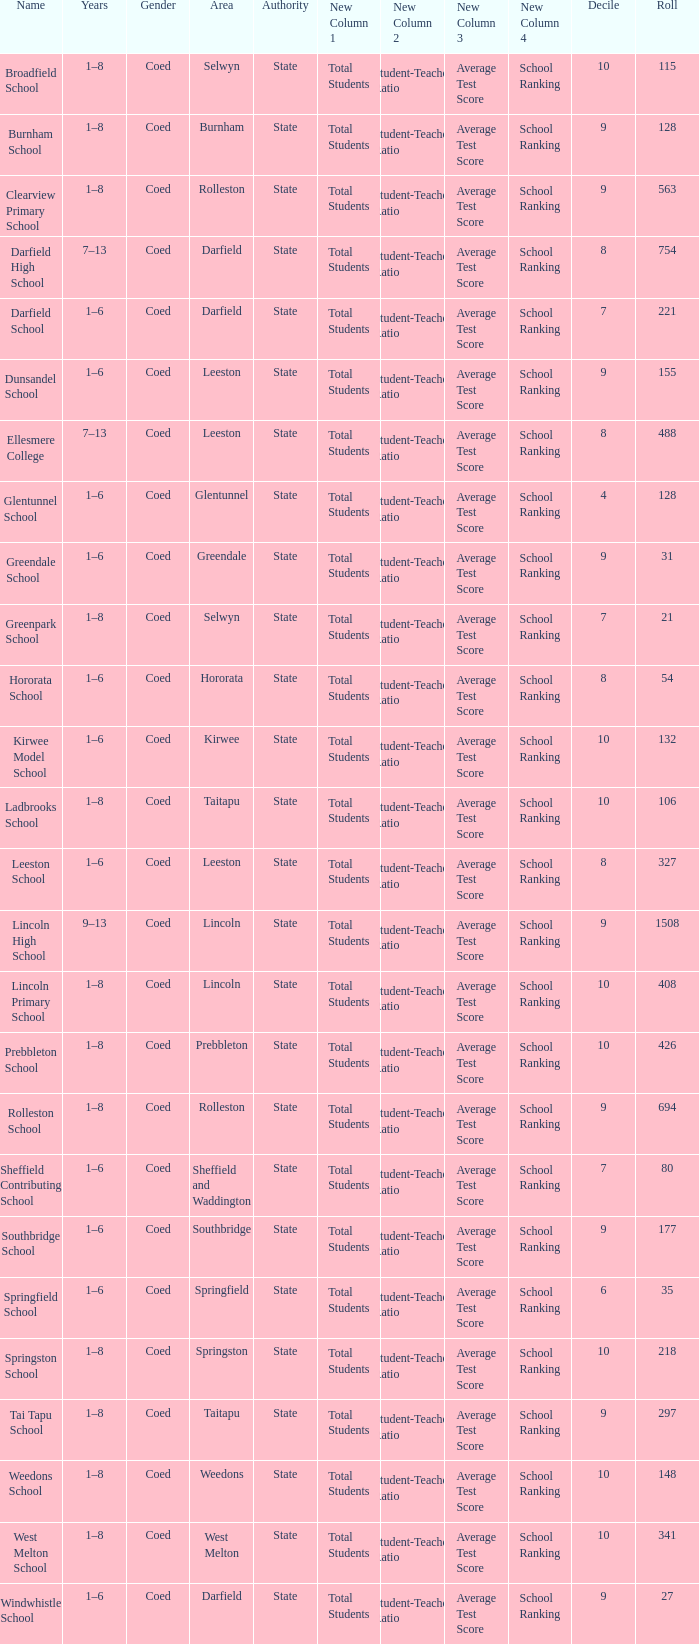Which years have a Name of ladbrooks school? 1–8. 